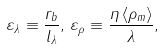Convert formula to latex. <formula><loc_0><loc_0><loc_500><loc_500>\varepsilon _ { \lambda } \equiv \frac { r _ { b } } { l _ { \lambda } } , \, \varepsilon _ { \rho } \equiv \frac { \eta \left \langle \rho _ { m } \right \rangle } { \lambda } ,</formula> 